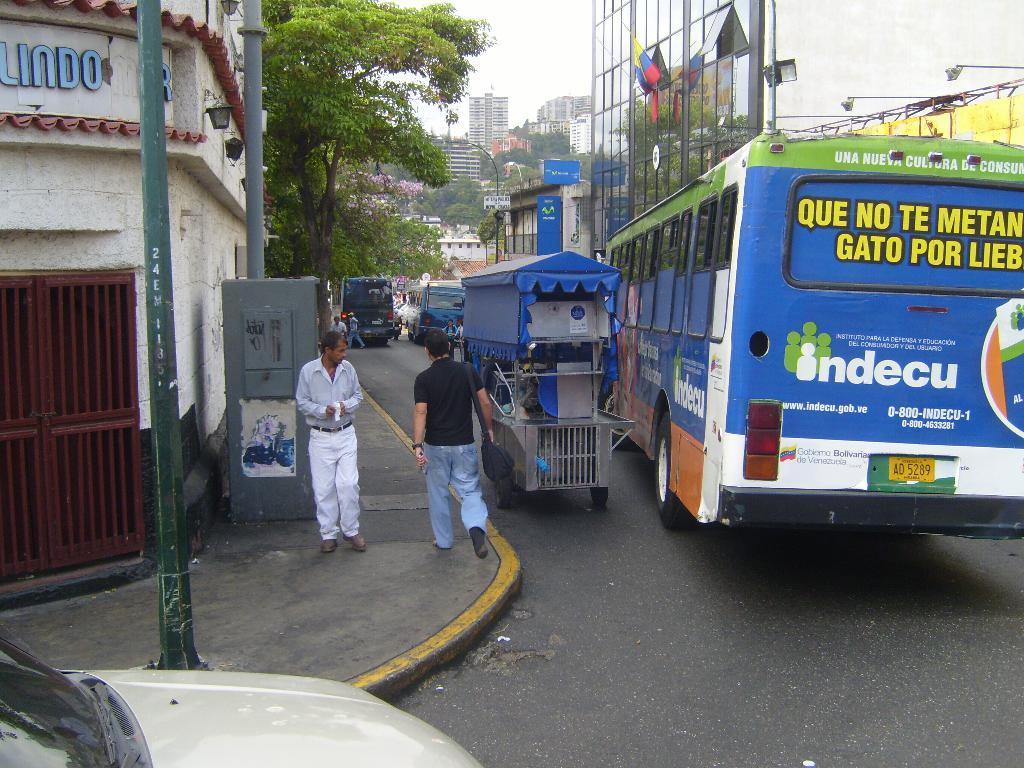How would you summarize this image in a sentence or two? In this image I can see vehicles and a crowd on the road. In the background I can see buildings, poles, trees and boards. On the top I can see the sky. This image is taken during a day. 